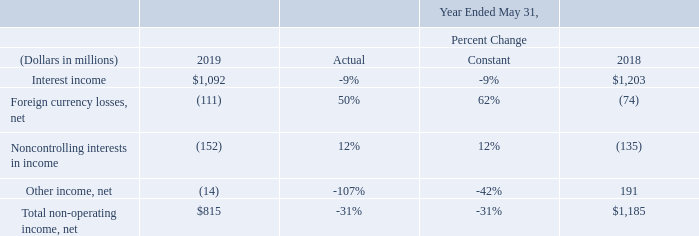Non-Operating Income, net: Non-operating income, net consists primarily of interest income, net foreign currency exchange losses, the noncontrolling interests in the net profits of our majority-owned subsidiaries (primarily Oracle Financial Services Software Limited and Oracle Corporation Japan) and net other income, including net recognized gains and losses related to all of our investments, net unrealized gains and losses related to the small portion of our investment portfolio related to our deferred compensation plan, net unrealized gains and losses related to certain equity securities and non-service net periodic pension income (losses).
On a constant currency basis, our non-operating income, net decreased in fiscal 2019 compared to fiscal 2018 primarily due to decreases in other income, net in fiscal 2019 , which was primarily attributable to realized gains on the sale of certa in marketable securities during fiscal 2018 , and lower interest income in fiscal 2019 primarily due to lower average cash, cash equivalent and marketable securities balances during fiscal 2019 .
How much was the average interest income in 2018 and 2019?
Answer scale should be: million. (1,092+1,203) / 2 
Answer: 1147.5. What was the difference in other income, net in 2019 and 2018?
Answer scale should be: million. 191 -(-14) 
Answer: 205. How much was the total amount of foreign currency losses, net and interest income across 2018 and 2019?
Answer scale should be: million. 1,092 + 1,203 - 111 - 74 
Answer: 2110. What is included in non-operating income? Non-operating income, net consists primarily of interest income, net foreign currency exchange losses, the noncontrolling interests in the net profits of our majority-owned subsidiaries (primarily oracle financial services software limited and oracle corporation japan) and net other income, including net recognized gains and losses related to all of our investments, net unrealized gains and losses related to the small portion of our investment portfolio related to our deferred compensation plan, net unrealized gains and losses related to certain equity securities and non-service net periodic pension income (losses). What are two of Oracle's majority-owned subsidiaries? Oracle financial services software limited and oracle corporation japan. Why did Oracle's interest income in fiscal 2019 decrease? Lower interest income in fiscal 2019 primarily due to lower average cash, cash equivalent and marketable securities balances during fiscal 2019 . 